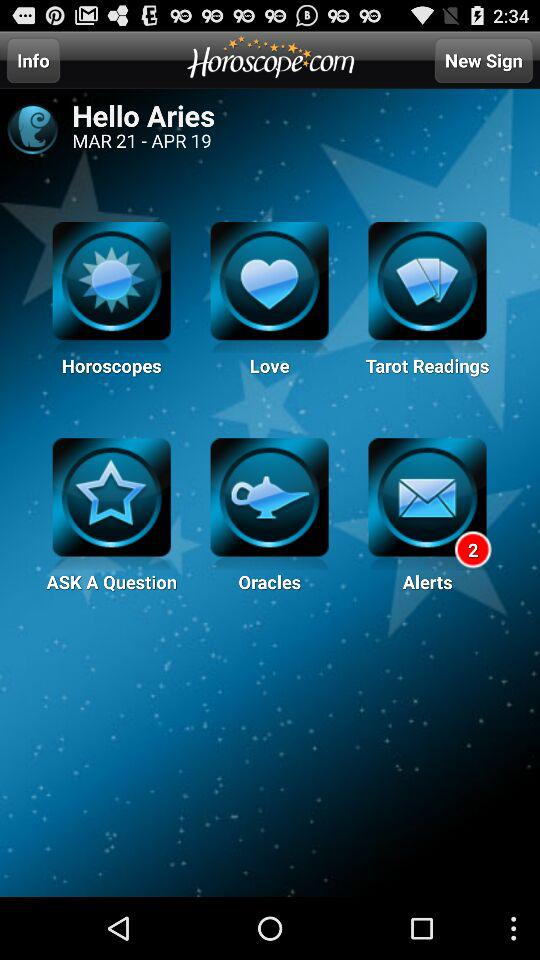What is the date range? The date range is from March 21 to April 19. 